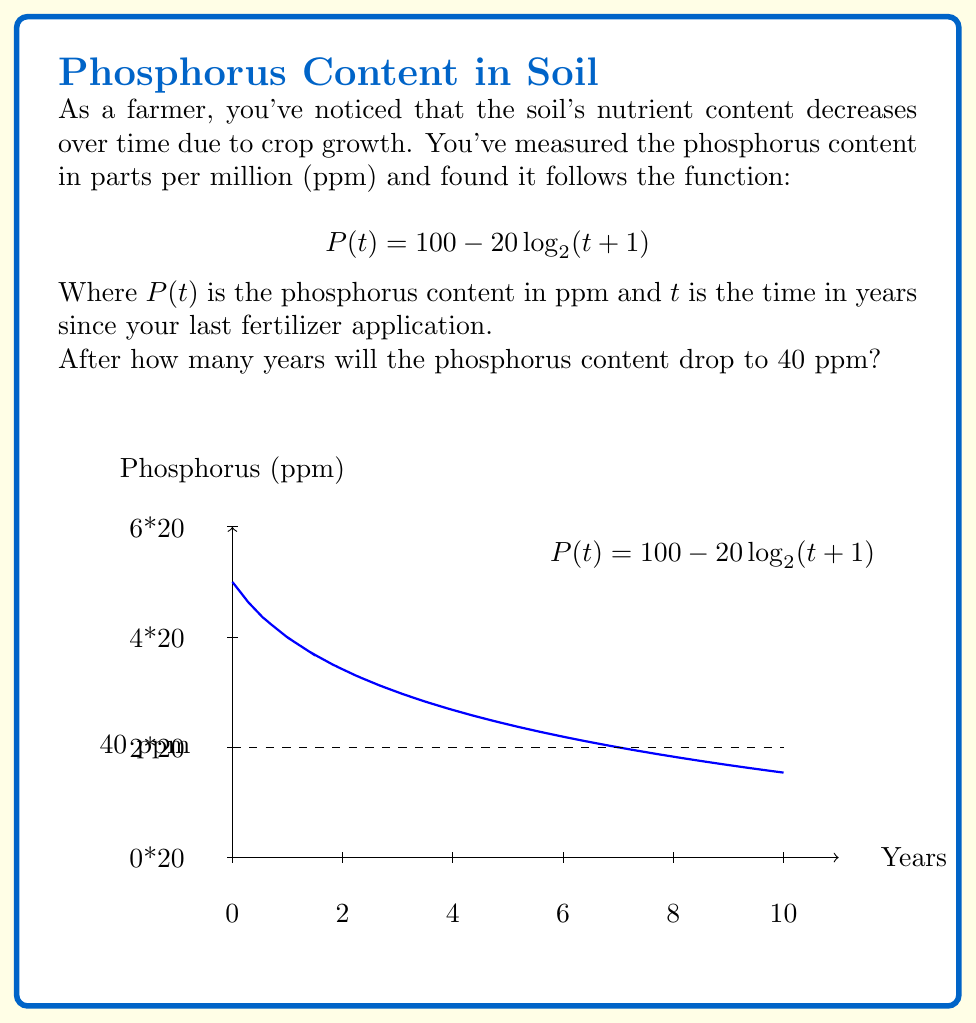Can you solve this math problem? Let's approach this step-by-step:

1) We need to find $t$ when $P(t) = 40$. So, we set up the equation:

   $$40 = 100 - 20\log_{2}(t+1)$$

2) Subtract 100 from both sides:

   $$-60 = -20\log_{2}(t+1)$$

3) Divide both sides by -20:

   $$3 = \log_{2}(t+1)$$

4) Now, we need to solve for $t$. We can do this by applying $2^x$ to both sides:

   $$2^3 = 2^{\log_{2}(t+1)}$$

5) Simplify the left side:

   $$8 = t+1$$

6) Subtract 1 from both sides:

   $$7 = t$$

Therefore, after 7 years, the phosphorus content will drop to 40 ppm.
Answer: 7 years 